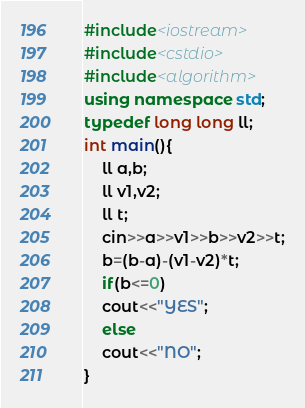<code> <loc_0><loc_0><loc_500><loc_500><_C++_>#include<iostream>
#include<cstdio>
#include<algorithm>
using namespace std;
typedef long long ll;
int main(){
	ll a,b;
	ll v1,v2;
	ll t;
	cin>>a>>v1>>b>>v2>>t;
	b=(b-a)-(v1-v2)*t;
	if(b<=0)
	cout<<"YES";
	else 
	cout<<"NO";
}</code> 